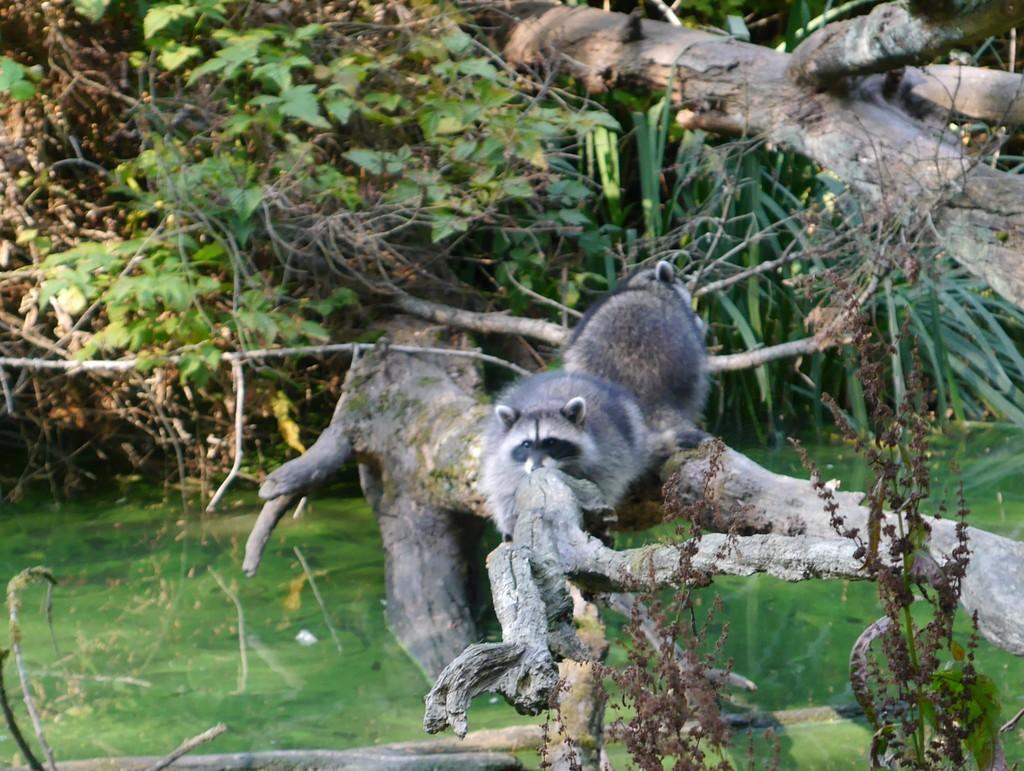What is the main subject of the image? There is an animal in the center of the image. Where is the animal located? The animal is on a branch of a tree. What can be seen in the background of the image? There are plants and dry trees in the background of the image. What type of popcorn is being served in the image? There is no popcorn present in the image. How does the animal's eye appear in the image? The image does not focus on the animal's eye, so it is not possible to describe its appearance. 